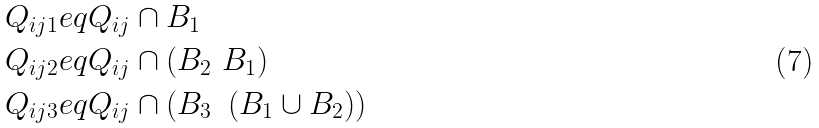<formula> <loc_0><loc_0><loc_500><loc_500>Q _ { i j 1 } & e q Q _ { i j } \cap B _ { 1 } \\ Q _ { i j 2 } & e q Q _ { i j } \cap \left ( B _ { 2 } \ B _ { 1 } \right ) \\ Q _ { i j 3 } & e q Q _ { i j } \cap \left ( B _ { 3 } \ \left ( B _ { 1 } \cup B _ { 2 } \right ) \right )</formula> 